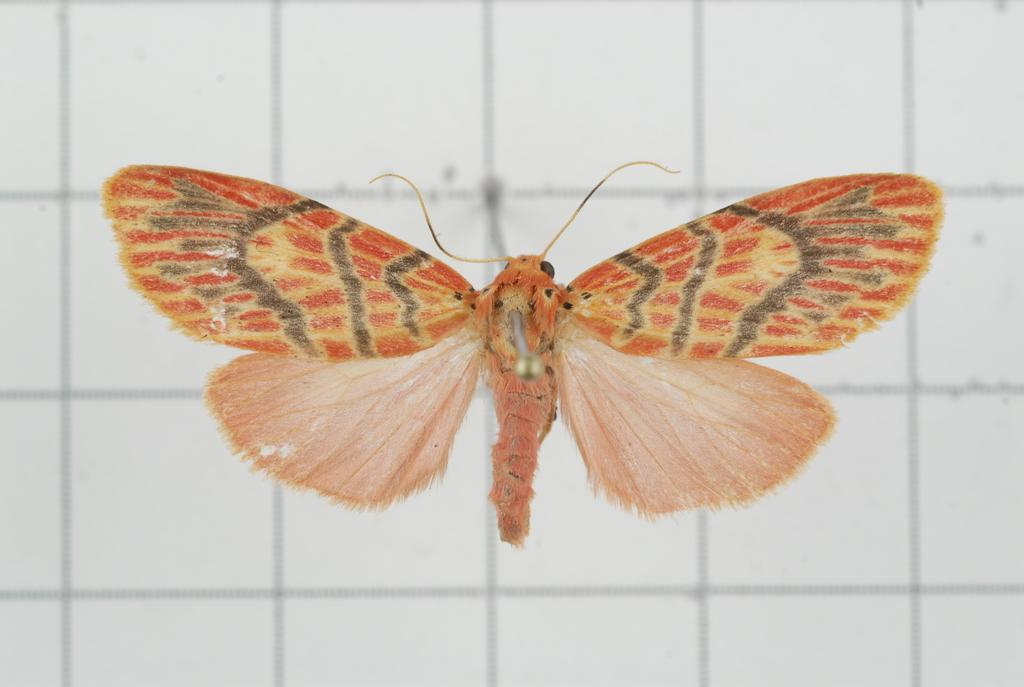What is the main subject of the image? There is a butterfly in the image. Where is the butterfly located in the image? The butterfly is in the center of the image. What type of vegetable is being used as a guide for the butterfly in the image? There is no vegetable or guide present in the image; it only features a butterfly in the center. 